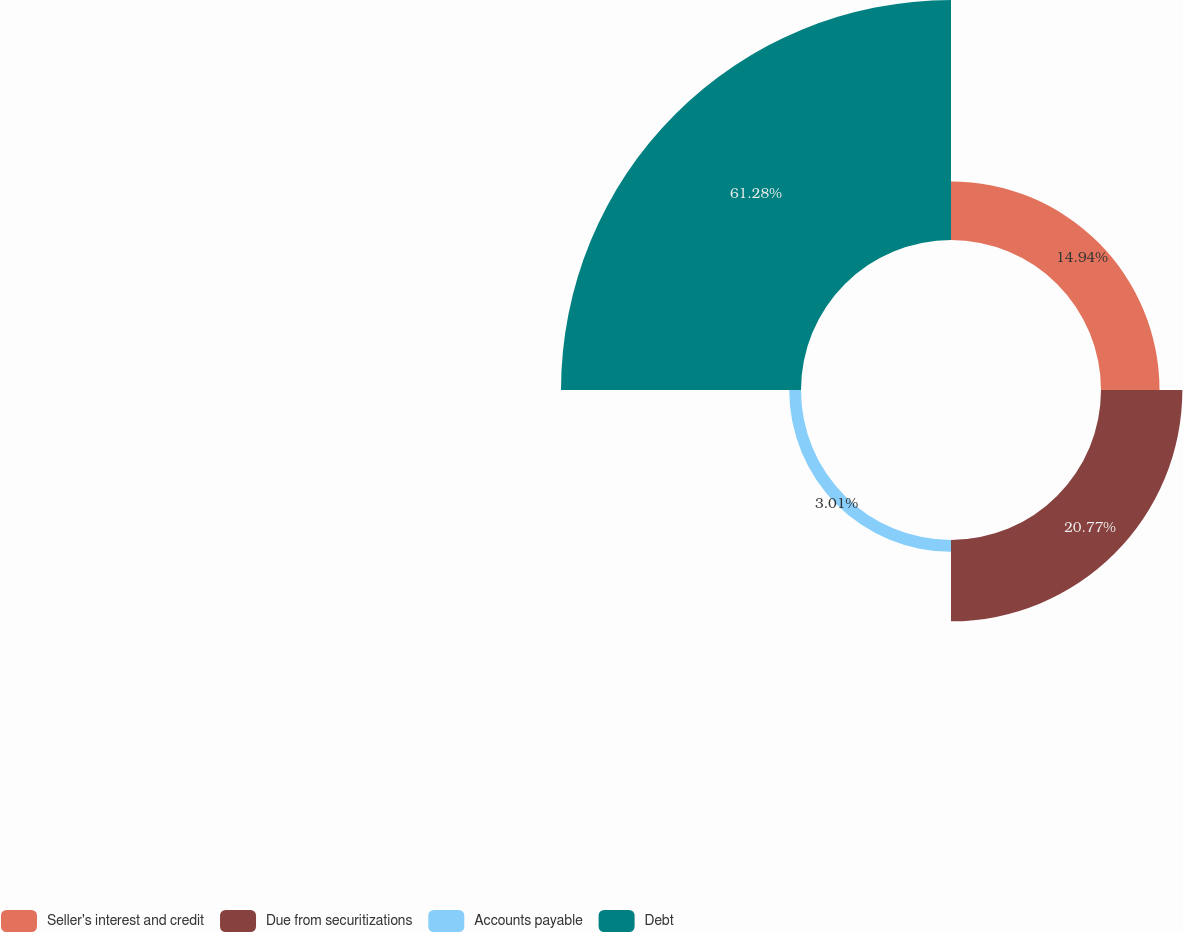Convert chart. <chart><loc_0><loc_0><loc_500><loc_500><pie_chart><fcel>Seller's interest and credit<fcel>Due from securitizations<fcel>Accounts payable<fcel>Debt<nl><fcel>14.94%<fcel>20.77%<fcel>3.01%<fcel>61.28%<nl></chart> 